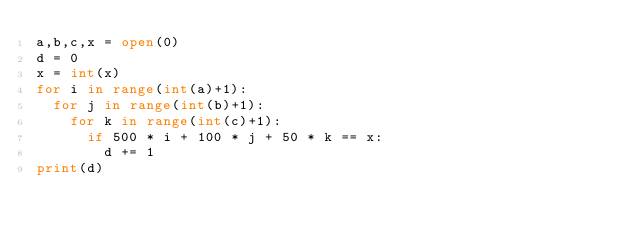Convert code to text. <code><loc_0><loc_0><loc_500><loc_500><_Python_>a,b,c,x = open(0)
d = 0
x = int(x)
for i in range(int(a)+1):
  for j in range(int(b)+1):
    for k in range(int(c)+1):
      if 500 * i + 100 * j + 50 * k == x:
        d += 1
print(d)</code> 